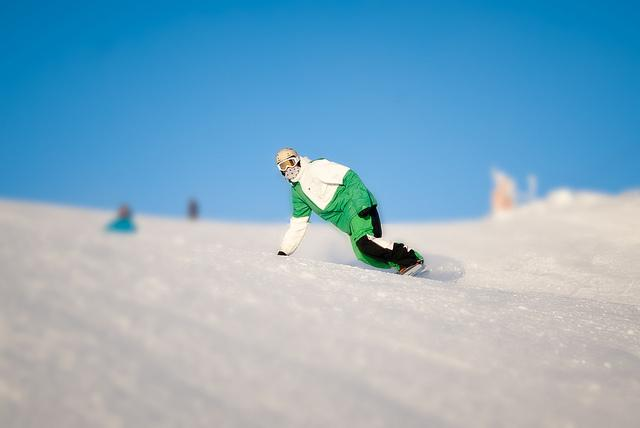The item the person is wearing on their face looks like what?

Choices:
A) chicken
B) gas mask
C) frog
D) scarf gas mask 